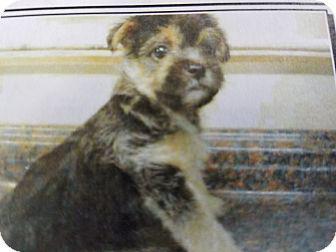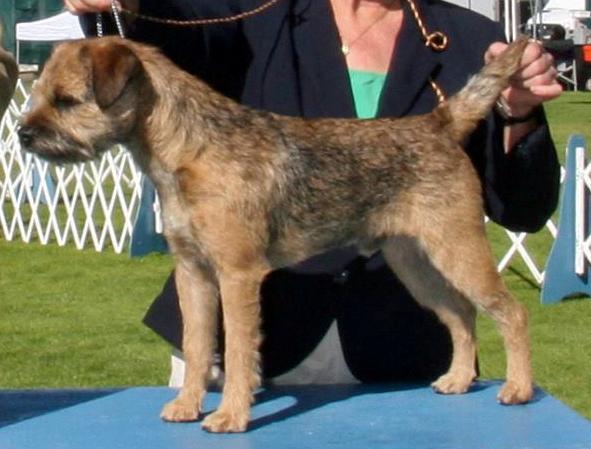The first image is the image on the left, the second image is the image on the right. Given the left and right images, does the statement "One dog's tongue is hanging out of its mouth." hold true? Answer yes or no. No. The first image is the image on the left, the second image is the image on the right. For the images shown, is this caption "One dog is sitting in the grass." true? Answer yes or no. No. 